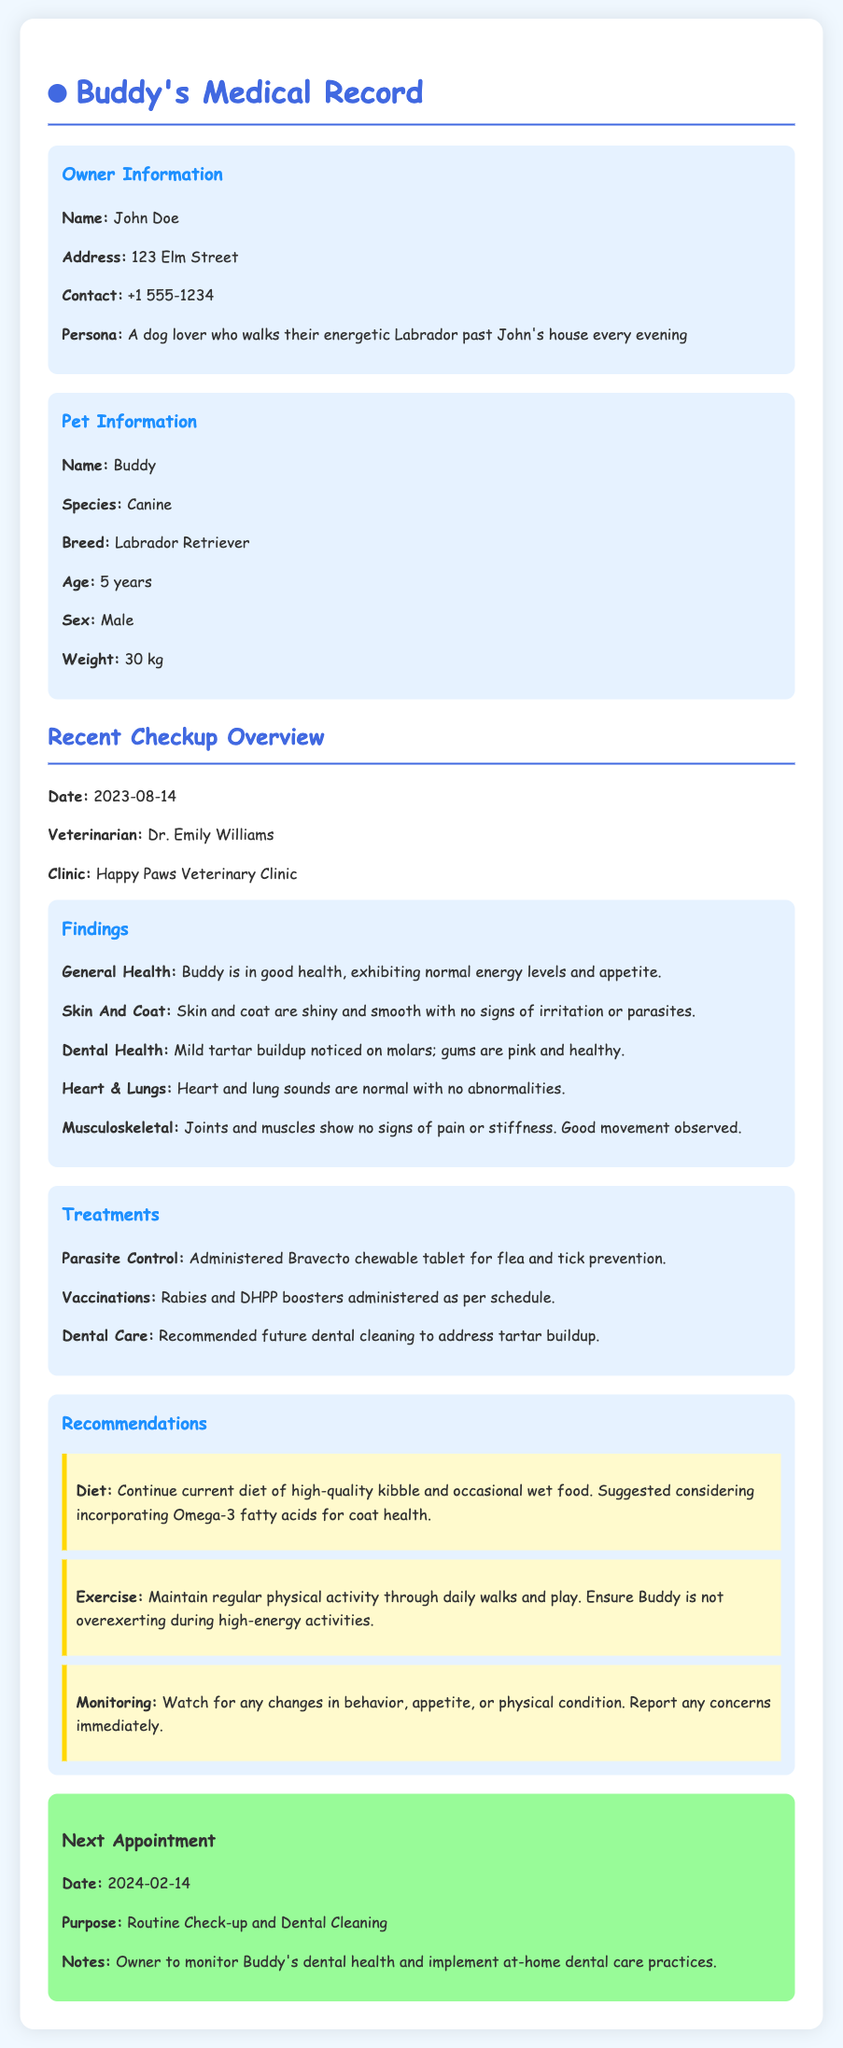What is Buddy's age? Buddy is mentioned as being 5 years old in the document.
Answer: 5 years Who is Buddy's veterinarian? The veterinarian listed in the most recent check-up is Dr. Emily Williams.
Answer: Dr. Emily Williams What was administered for flea and tick prevention? The document states that a Bravecto chewable tablet was administered for flea and tick prevention.
Answer: Bravecto chewable tablet What health issue was noted in Buddy's dental health? It was noted that there is mild tartar buildup on Buddy's molars.
Answer: Mild tartar buildup What is the next appointment date? The next appointment is scheduled for February 14, 2024.
Answer: 2024-02-14 What type of diet is recommended for Buddy? The recommended diet consists of high-quality kibble and occasional wet food.
Answer: High-quality kibble and occasional wet food What is the purpose of Buddy's next appointment? The document indicates that the purpose of the next appointment is a routine check-up and dental cleaning.
Answer: Routine Check-up and Dental Cleaning What should be monitored according to the recommendations? The recommendation is to monitor any changes in behavior, appetite, or physical condition.
Answer: Changes in behavior, appetite, or physical condition 